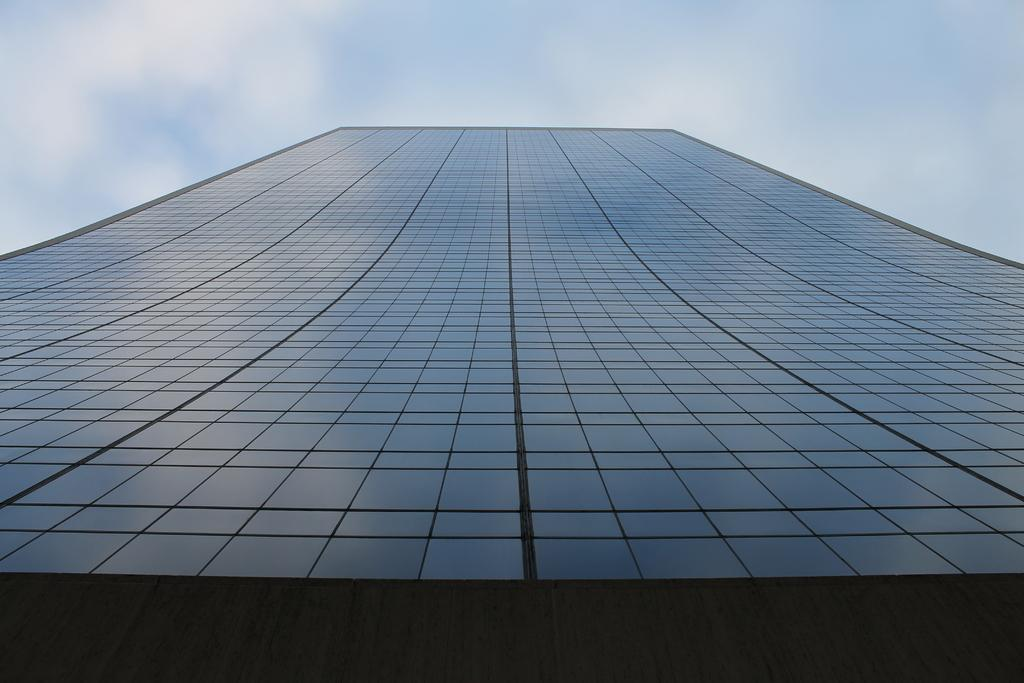What is the perspective of the image? The image is taken from a low angle. What type of building can be seen in the image? There is a glass building in the image. What can be seen in the background of the image? The sky is visible in the background of the image. What is the condition of the sky in the image? Clouds are present in the sky. How many trucks are visible in the image? There are no trucks present in the image. What type of debt is being discussed in the image? There is no mention of debt in the image. 